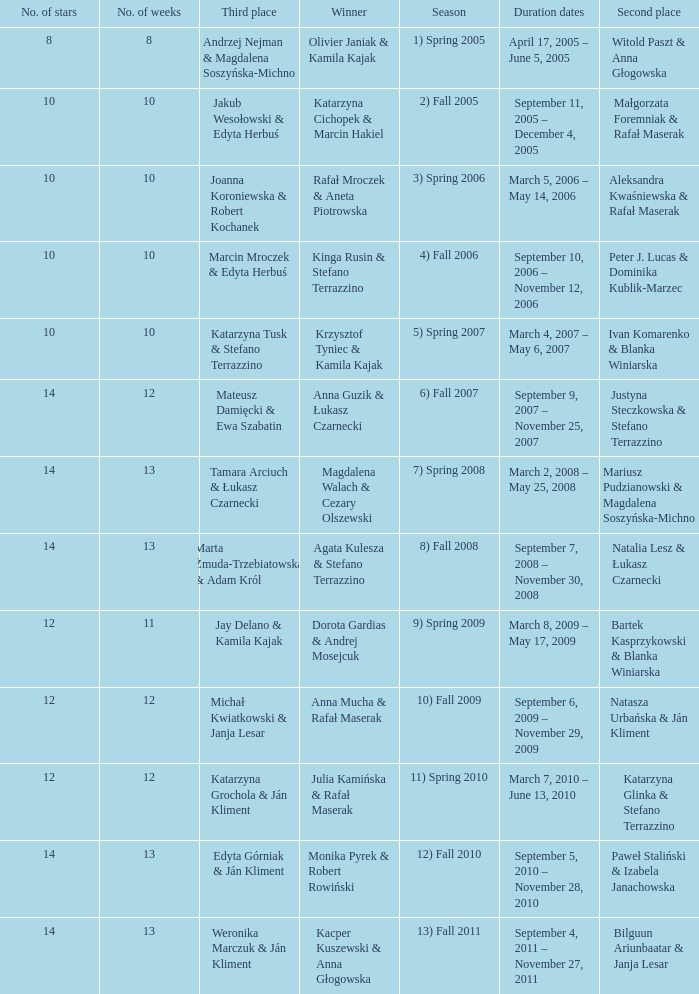Who got second place when the winners were rafał mroczek & aneta piotrowska? Aleksandra Kwaśniewska & Rafał Maserak. 